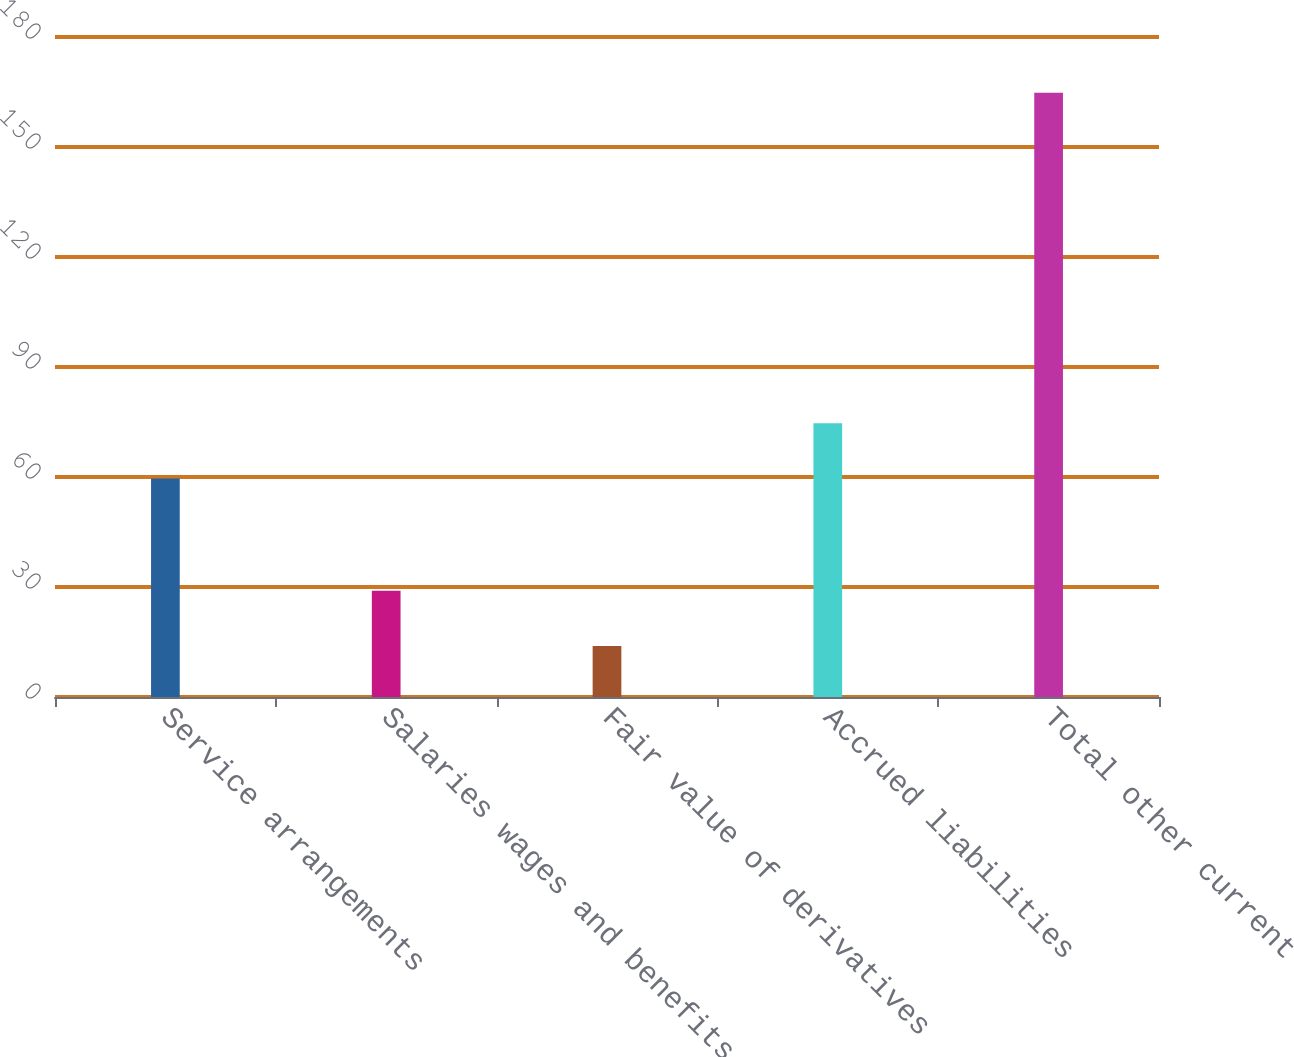Convert chart to OTSL. <chart><loc_0><loc_0><loc_500><loc_500><bar_chart><fcel>Service arrangements<fcel>Salaries wages and benefits<fcel>Fair value of derivatives<fcel>Accrued liabilities<fcel>Total other current<nl><fcel>59.6<fcel>29<fcel>13.9<fcel>74.69<fcel>164.8<nl></chart> 